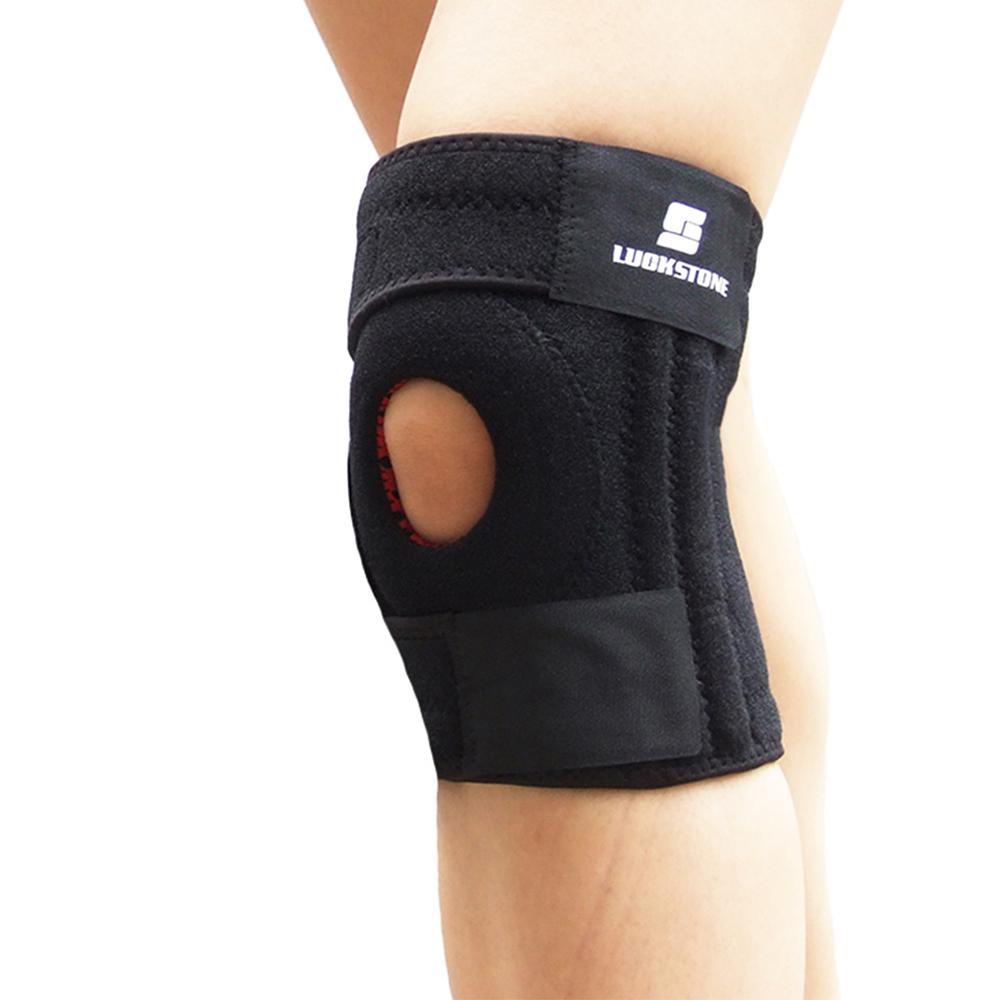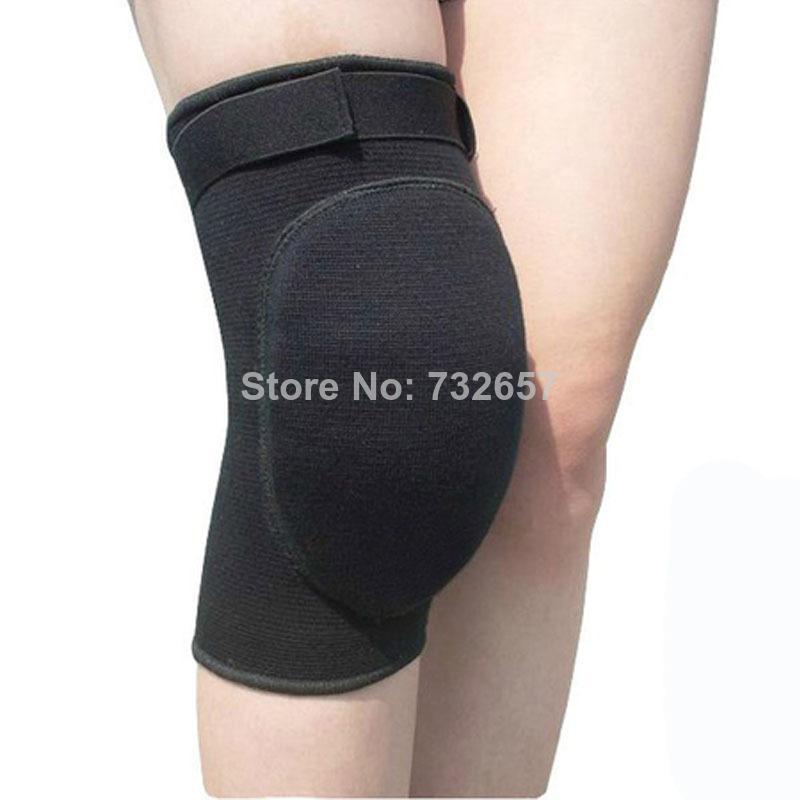The first image is the image on the left, the second image is the image on the right. For the images displayed, is the sentence "One of the knee-pads has Velcro around the top and one does not." factually correct? Answer yes or no. No. 